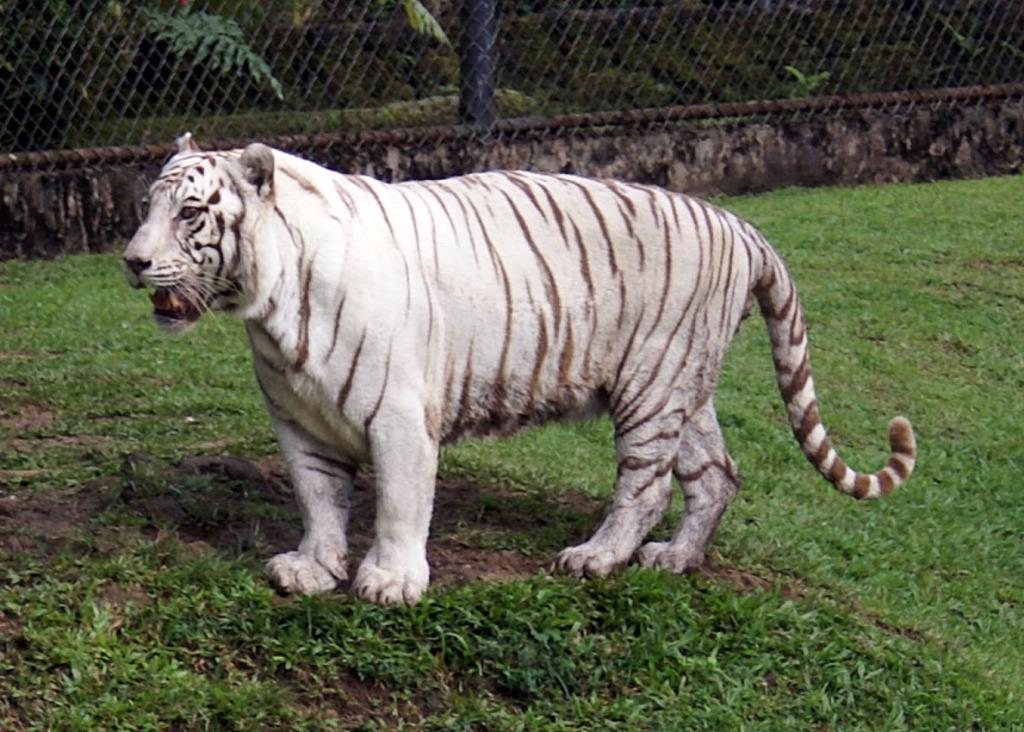What animal is located in the middle of the image? There is a tiger in the middle of the image. What type of vegetation is at the bottom of the image? There is grass at the bottom of the image. What can be seen in the background of the image? There are plants, trees, and a net in the background of the image. What type of corn is growing in the image? There is no corn present in the image. What is on the list that the tiger is holding in the image? There is no list present in the image; the tiger is not holding anything. 